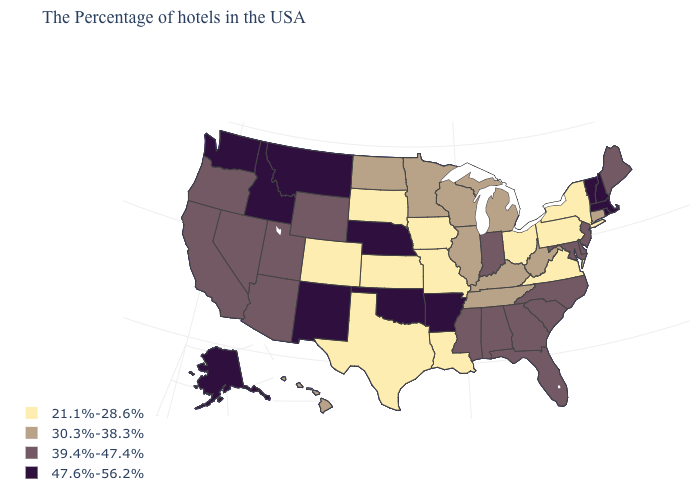Name the states that have a value in the range 39.4%-47.4%?
Concise answer only. Maine, New Jersey, Delaware, Maryland, North Carolina, South Carolina, Florida, Georgia, Indiana, Alabama, Mississippi, Wyoming, Utah, Arizona, Nevada, California, Oregon. How many symbols are there in the legend?
Short answer required. 4. How many symbols are there in the legend?
Answer briefly. 4. Which states have the highest value in the USA?
Give a very brief answer. Massachusetts, Rhode Island, New Hampshire, Vermont, Arkansas, Nebraska, Oklahoma, New Mexico, Montana, Idaho, Washington, Alaska. Among the states that border New Mexico , does Oklahoma have the highest value?
Give a very brief answer. Yes. Which states have the highest value in the USA?
Write a very short answer. Massachusetts, Rhode Island, New Hampshire, Vermont, Arkansas, Nebraska, Oklahoma, New Mexico, Montana, Idaho, Washington, Alaska. Does Massachusetts have the same value as Iowa?
Short answer required. No. Does Arizona have the same value as Indiana?
Write a very short answer. Yes. Does Nebraska have the highest value in the MidWest?
Be succinct. Yes. How many symbols are there in the legend?
Be succinct. 4. Name the states that have a value in the range 30.3%-38.3%?
Quick response, please. Connecticut, West Virginia, Michigan, Kentucky, Tennessee, Wisconsin, Illinois, Minnesota, North Dakota, Hawaii. Name the states that have a value in the range 21.1%-28.6%?
Quick response, please. New York, Pennsylvania, Virginia, Ohio, Louisiana, Missouri, Iowa, Kansas, Texas, South Dakota, Colorado. What is the value of Wyoming?
Concise answer only. 39.4%-47.4%. What is the highest value in states that border Georgia?
Write a very short answer. 39.4%-47.4%. What is the value of Pennsylvania?
Write a very short answer. 21.1%-28.6%. 